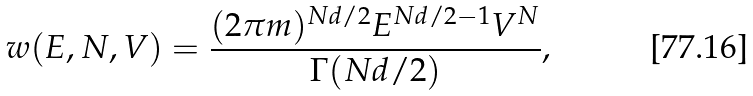Convert formula to latex. <formula><loc_0><loc_0><loc_500><loc_500>\ w ( E , N , V ) = \frac { ( 2 \pi m ) ^ { N d / 2 } E ^ { N d / 2 - 1 } V ^ { N } } { \Gamma ( N d / 2 ) } ,</formula> 